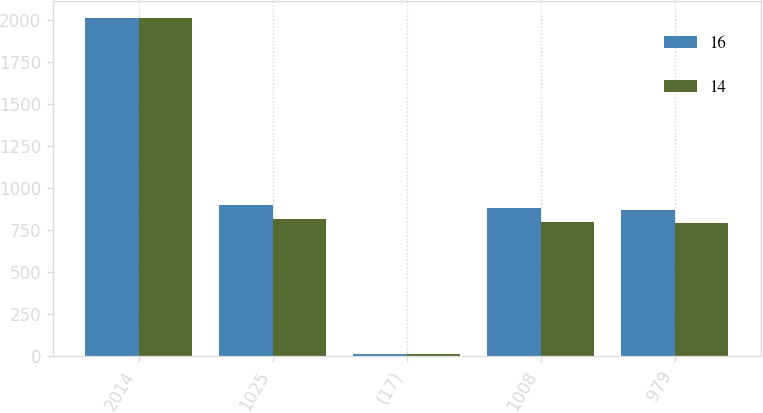Convert chart. <chart><loc_0><loc_0><loc_500><loc_500><stacked_bar_chart><ecel><fcel>2014<fcel>1025<fcel>(17)<fcel>1008<fcel>979<nl><fcel>16<fcel>2013<fcel>900<fcel>16<fcel>884<fcel>868<nl><fcel>14<fcel>2012<fcel>814<fcel>13<fcel>801<fcel>795<nl></chart> 